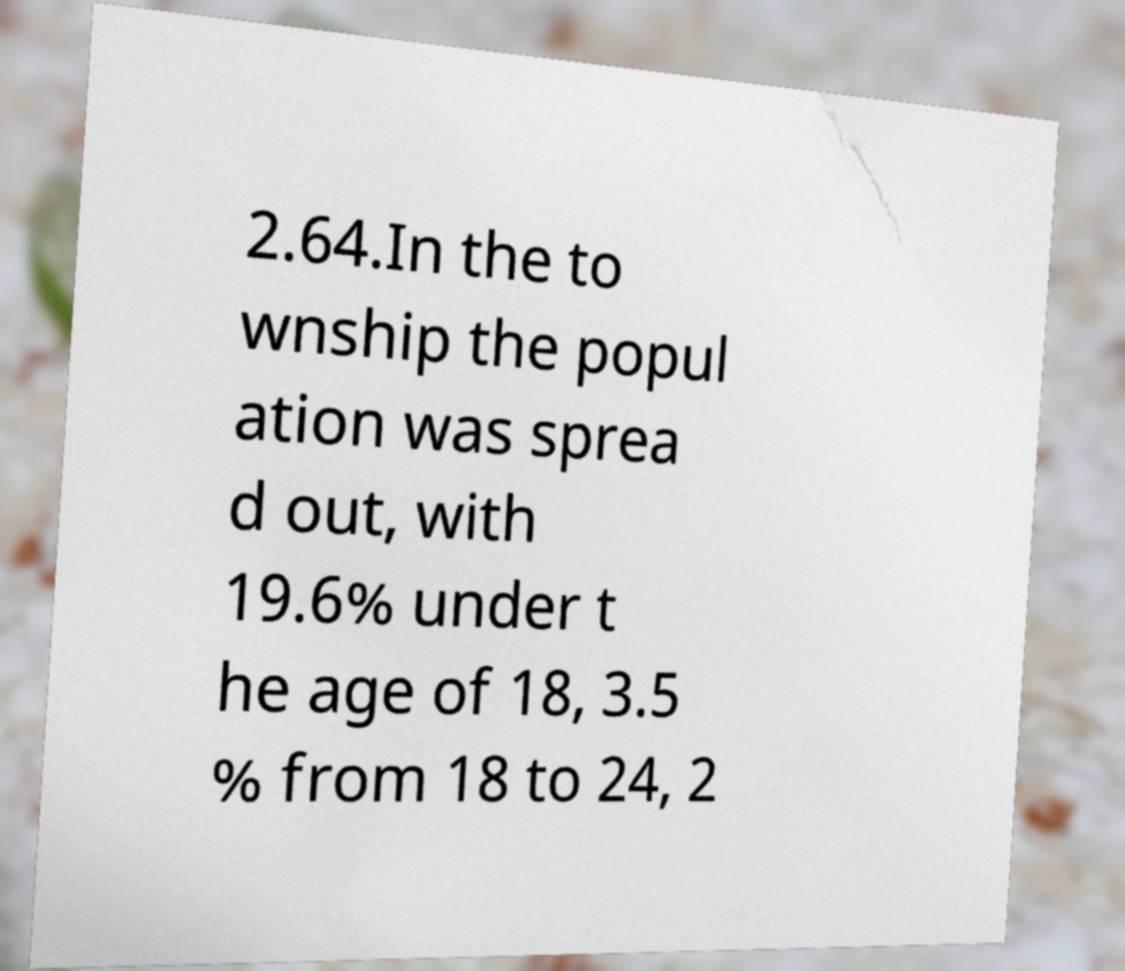There's text embedded in this image that I need extracted. Can you transcribe it verbatim? 2.64.In the to wnship the popul ation was sprea d out, with 19.6% under t he age of 18, 3.5 % from 18 to 24, 2 